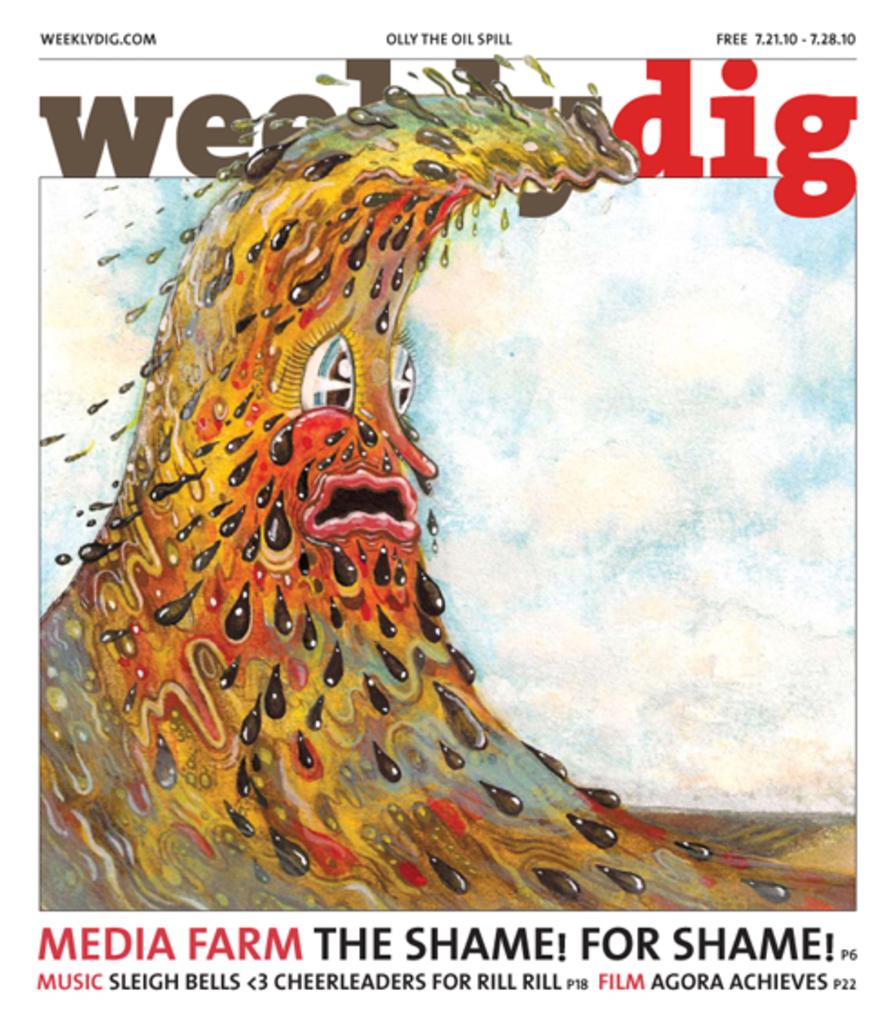What is the title next to film?
Your response must be concise. Agora achieves. 